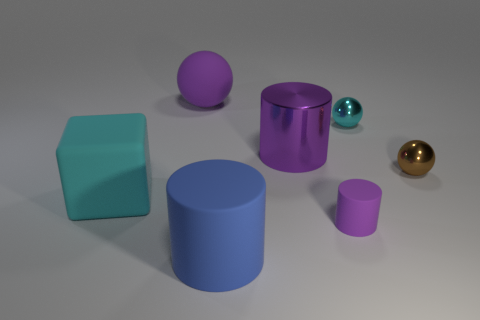Subtract all metal balls. How many balls are left? 1 Add 1 small rubber cylinders. How many objects exist? 8 Subtract all blue cylinders. How many cylinders are left? 2 Subtract all purple blocks. How many purple cylinders are left? 2 Subtract all cyan cylinders. Subtract all purple blocks. How many cylinders are left? 3 Subtract all balls. How many objects are left? 4 Subtract 1 cylinders. How many cylinders are left? 2 Subtract all large cyan cubes. Subtract all brown shiny things. How many objects are left? 5 Add 2 purple rubber balls. How many purple rubber balls are left? 3 Add 6 tiny cyan things. How many tiny cyan things exist? 7 